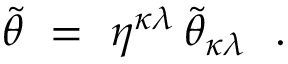Convert formula to latex. <formula><loc_0><loc_0><loc_500><loc_500>\tilde { \theta } = \eta ^ { \kappa \lambda } \, \tilde { \theta } _ { \kappa \lambda } .</formula> 